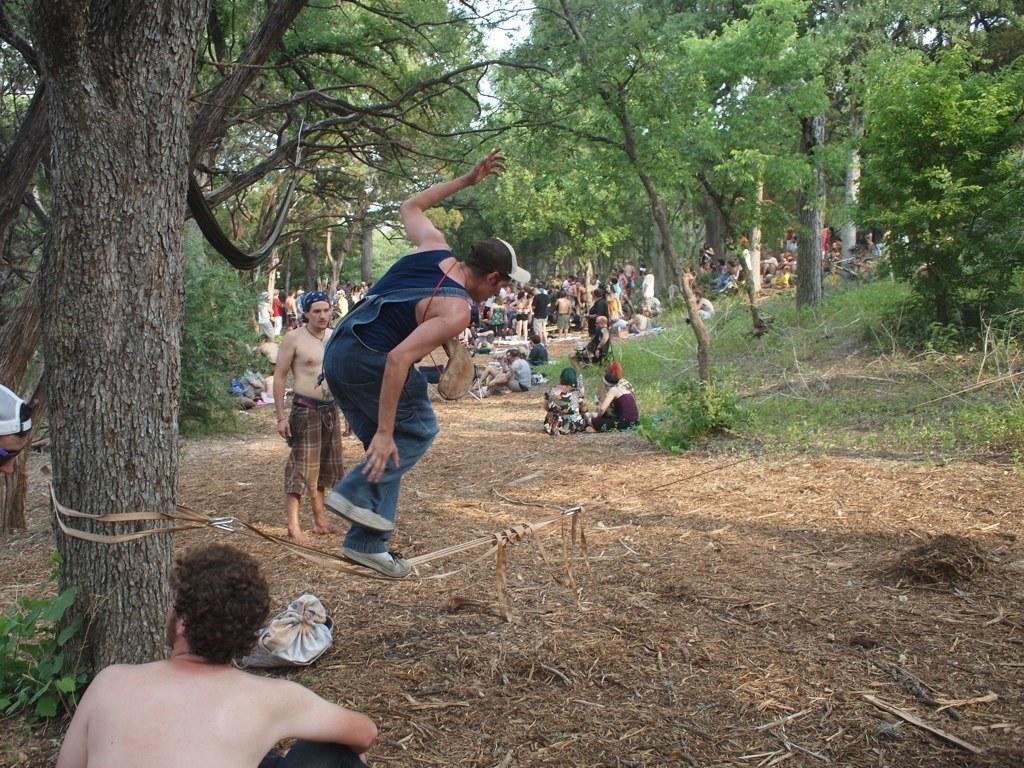In one or two sentences, can you explain what this image depicts? In this image there is one person jumping as we can see in the middle of this image. There are some persons in the background. There are some trees on the top of this image. There is one person sitting in the bottom of this image. and there is a ground as we can see in the bottom of this image. 